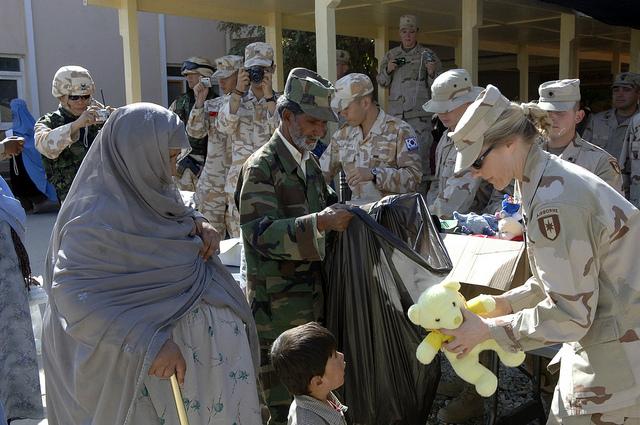Was this picture taken at sunset?
Answer briefly. No. What is the yellow object the military personnel is holding?
Quick response, please. Teddy bear. Are people taking pictures?
Write a very short answer. Yes. What is the predominant clothing color?
Answer briefly. Tan. Is the bear alive?
Answer briefly. No. 